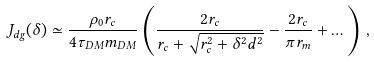<formula> <loc_0><loc_0><loc_500><loc_500>J _ { d g } ( \delta ) \simeq \frac { \rho _ { 0 } r _ { c } } { 4 \tau _ { D M } m _ { D M } } \left ( \frac { 2 r _ { c } } { r _ { c } + \sqrt { r _ { c } ^ { 2 } + \delta ^ { 2 } d ^ { 2 } } } - \frac { 2 r _ { c } } { \pi r _ { m } } + \dots \right ) \, ,</formula> 